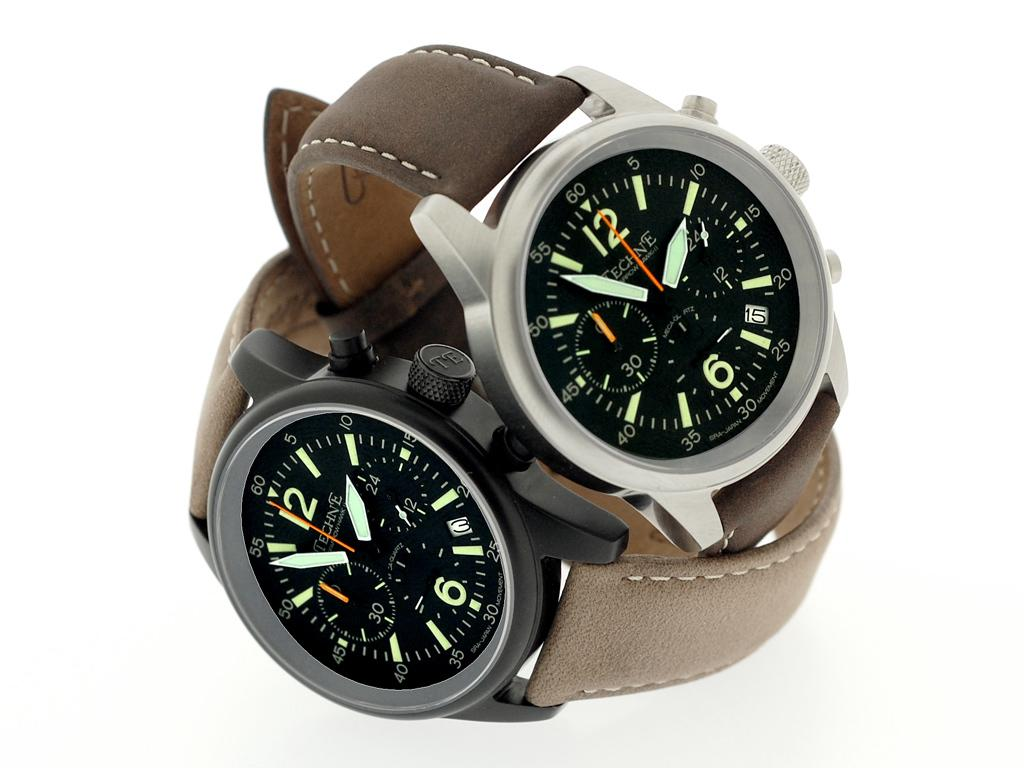<image>
Relay a brief, clear account of the picture shown. Two TechOne watches with knobs on side, leather wrist straps, 3 different faces in one. 